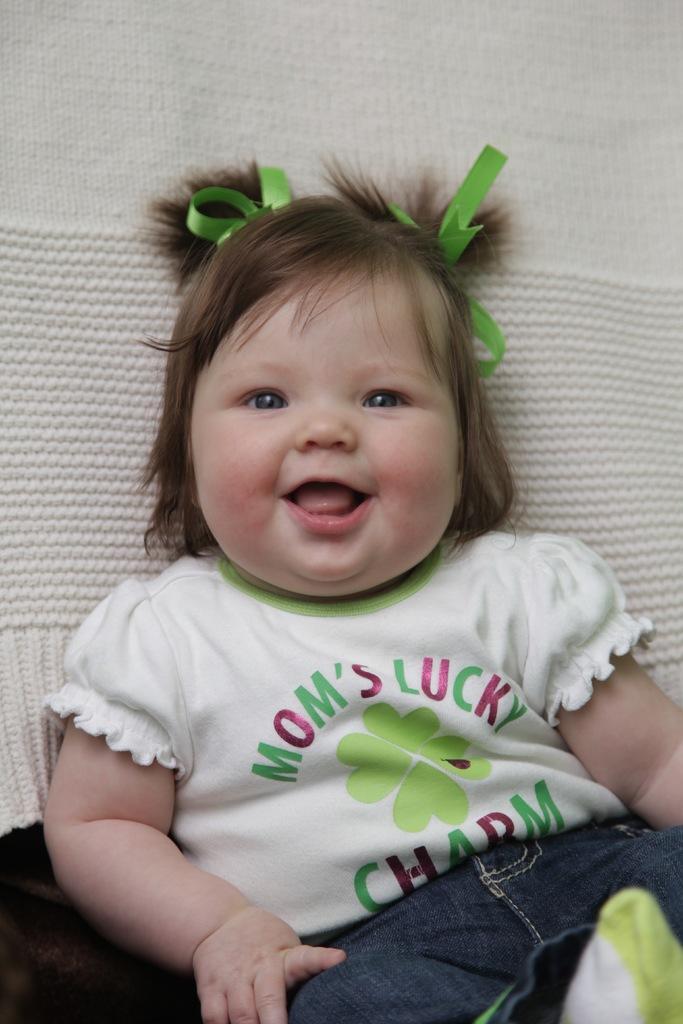Please provide a concise description of this image. In this image, we can see a baby wearing clothes. In the background, there is a cloth. 